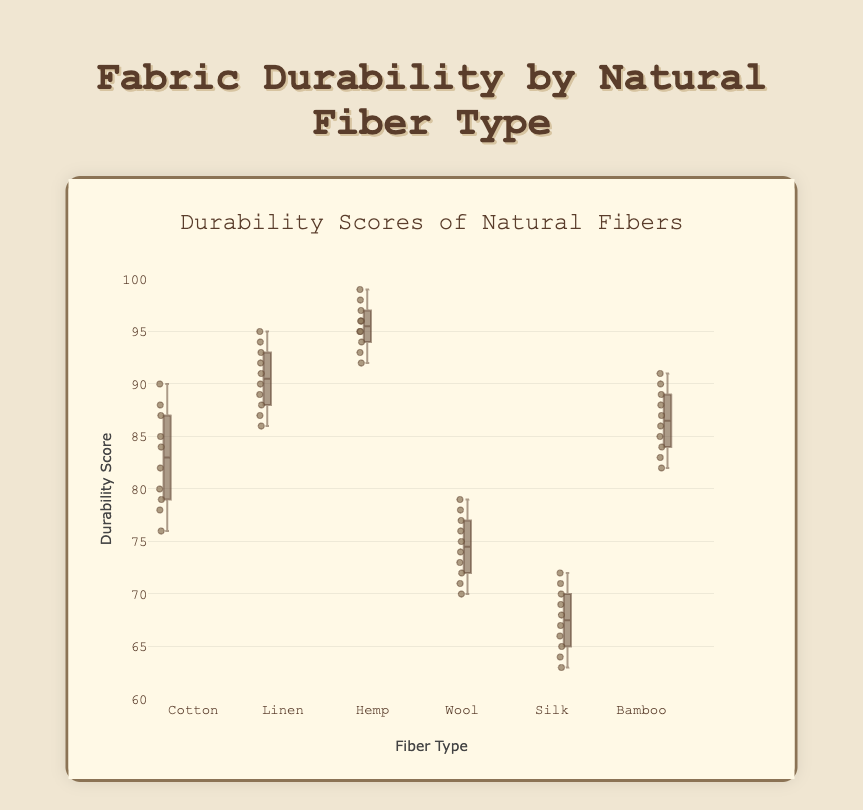what is the title of the box plot? The title is displayed at the top of the figure.
Answer: Fabric Durability by Natural Fiber Type which fiber type has the highest median durability score? The median is the line inside the box. The highest median is observed in the "Hemp" fiber box.
Answer: Hemp which fiber type has the lowest median durability score? The median line inside the box of "Silk" is the lowest among all fiber types.
Answer: Silk what is the range of the durability scores for cotton? The range of a box plot extends from the minimum (bottom whisker) to the maximum (top whisker) durability scores. For Cotton, it ranges from 76 to 90.
Answer: 76 to 90 what is the interquartile range (IQR) of linen? The IQR is the height of the box, representing the range between the first quartile (bottom of the box) and third quartile (top of the box). For Linen, the first quartile is at 88, and the third quartile is at 94, so the IQR is 94 - 88.
Answer: 6 which fiber type shows the most variability in durability scores? Variability can be assessed by the length of the whiskers and the box. Silk has the longest whiskers and box, indicating the most variability.
Answer: Silk which fiber types have outliers and how can you identify them? Outliers are points outside the whiskers. The figure shows outliers as individual points. Wool and Bamboo have no visible outliers in the figure.
Answer: Bamboo, Wool (none visible) how does the average durability score of bamboo compare to wool? By observing the position of the middle line in the boxes and the distribution of points, one can estimate average scores. Bamboo's middle line (median) is higher than Wool's. Overall, Bamboo's average is higher.
Answer: Bamboo's average is higher between cotton and linen, which fiber type has more consistent durability scores? Consistency in durability scores is shown by a shorter IQR and narrower whiskers. Linen has a shorter IQR and whiskers compared to Cotton, indicating more consistency.
Answer: Linen what would you expect to be the median score if combining all fiber types together? To find this, it's beneficial to recognize the middle value if all the data points were combined and ordered. Given the general spread and the distribution, an estimate around 80-85 seems reasonable.
Answer: Around 80-85 